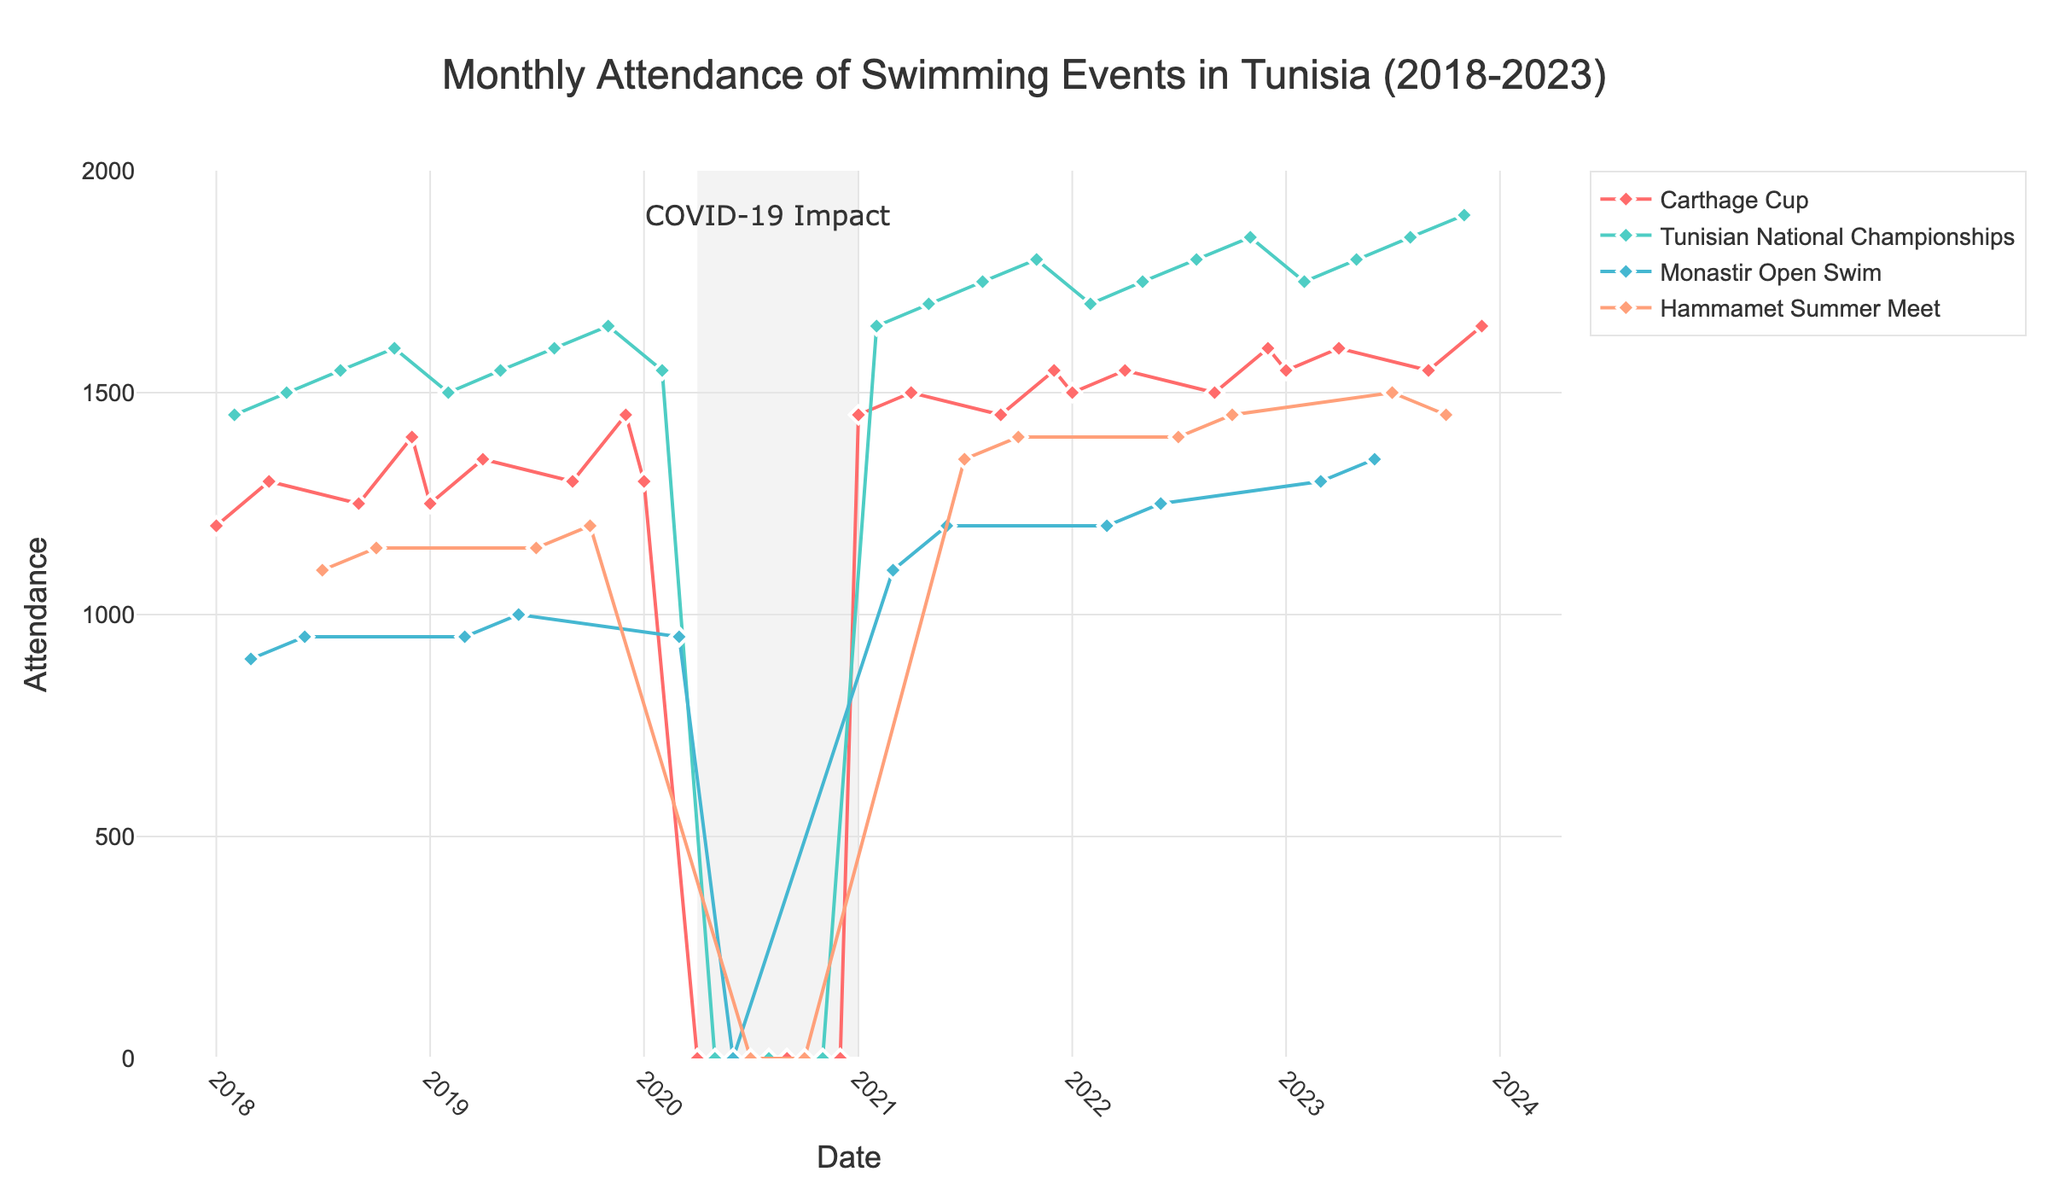What is the title of the figure? The title is located at the top of the figure and is designed to give a clear summary of what the figure depicts.
Answer: Monthly Attendance of Swimming Events in Tunisia (2018-2023) What is the range of attendance values on the y-axis? The y-axis represents attendance values, with the range starting from the lowest value and extending to the highest value specified on the axis.
Answer: 0 to 2000 Which event had the highest attendance in 2023? To determine this, observe the data points for each event in the year 2023 and identify which event's data point is the highest. The point for November 2023 of the Tunisian National Championships reaches the maximum attendance.
Answer: Tunisian National Championships (November 2023) Why is there a shaded vertical rectangle in the year 2020? The shaded rectangle in 2020 highlights a specific period and the annotation inside it provides additional context. The annotation "COVID-19 Impact" is placed within this shaded area, indicating its purpose.
Answer: COVID-19 Impact What was the attendance for the Carthage Cup in April 2020? The attendance value for April 2020 can be found by locating the corresponding point for the Carthage Cup event. In this case, it is at the bottom, indicating zero attendance.
Answer: 0 Which month in 2022 had the highest event attendance, and what was the value? This involves examining all data points for each month in 2022 and identifying the highest one. The point for November 2022, which corresponds to the Tunisian National Championships, has the maximum attendance.
Answer: November 2022, 1850 How did attendance for swimming events change from March 2020 to April 2020? By comparing the attendance values for these two months, we can notice the drop from 950 in March to 0 in April, likely due to COVID-19.
Answer: It dropped to 0 Which event shows the most consistent attendance over the years? To find this, follow the trend lines for each event. The Tunisian National Championships show a generally upward-trending, consistent pattern compared to others.
Answer: Tunisian National Championships What can you infer about the trend of swimming event attendance from 2018 to 2023? By analyzing the general direction of the data points, it's clear that there is an upward trend in attendance over these years, especially for the Tunisian National Championships.
Answer: Upward trend 